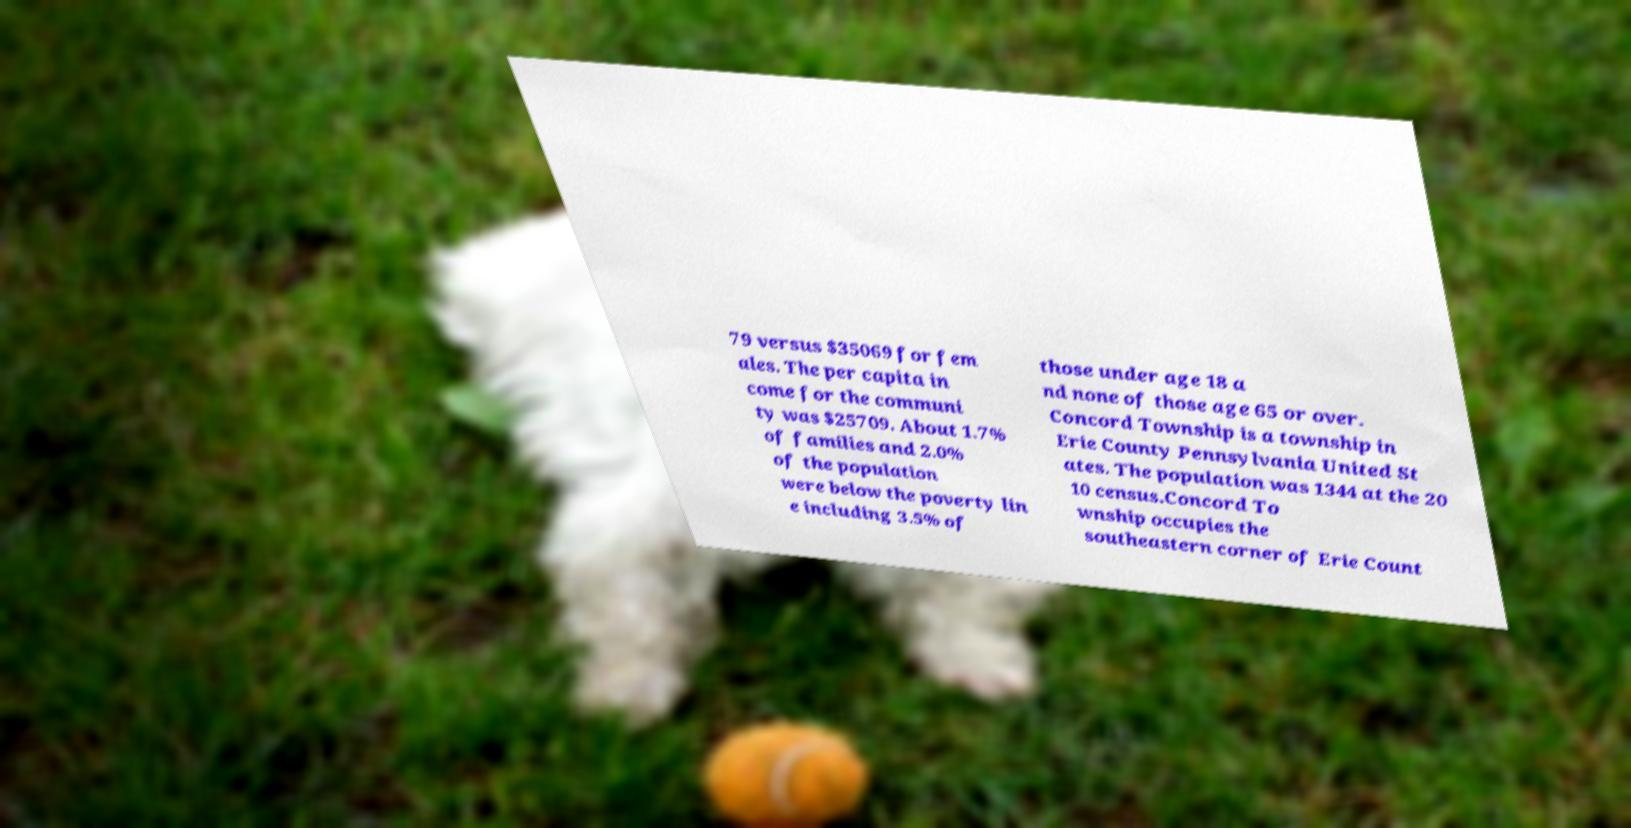For documentation purposes, I need the text within this image transcribed. Could you provide that? 79 versus $35069 for fem ales. The per capita in come for the communi ty was $25709. About 1.7% of families and 2.0% of the population were below the poverty lin e including 3.5% of those under age 18 a nd none of those age 65 or over. Concord Township is a township in Erie County Pennsylvania United St ates. The population was 1344 at the 20 10 census.Concord To wnship occupies the southeastern corner of Erie Count 